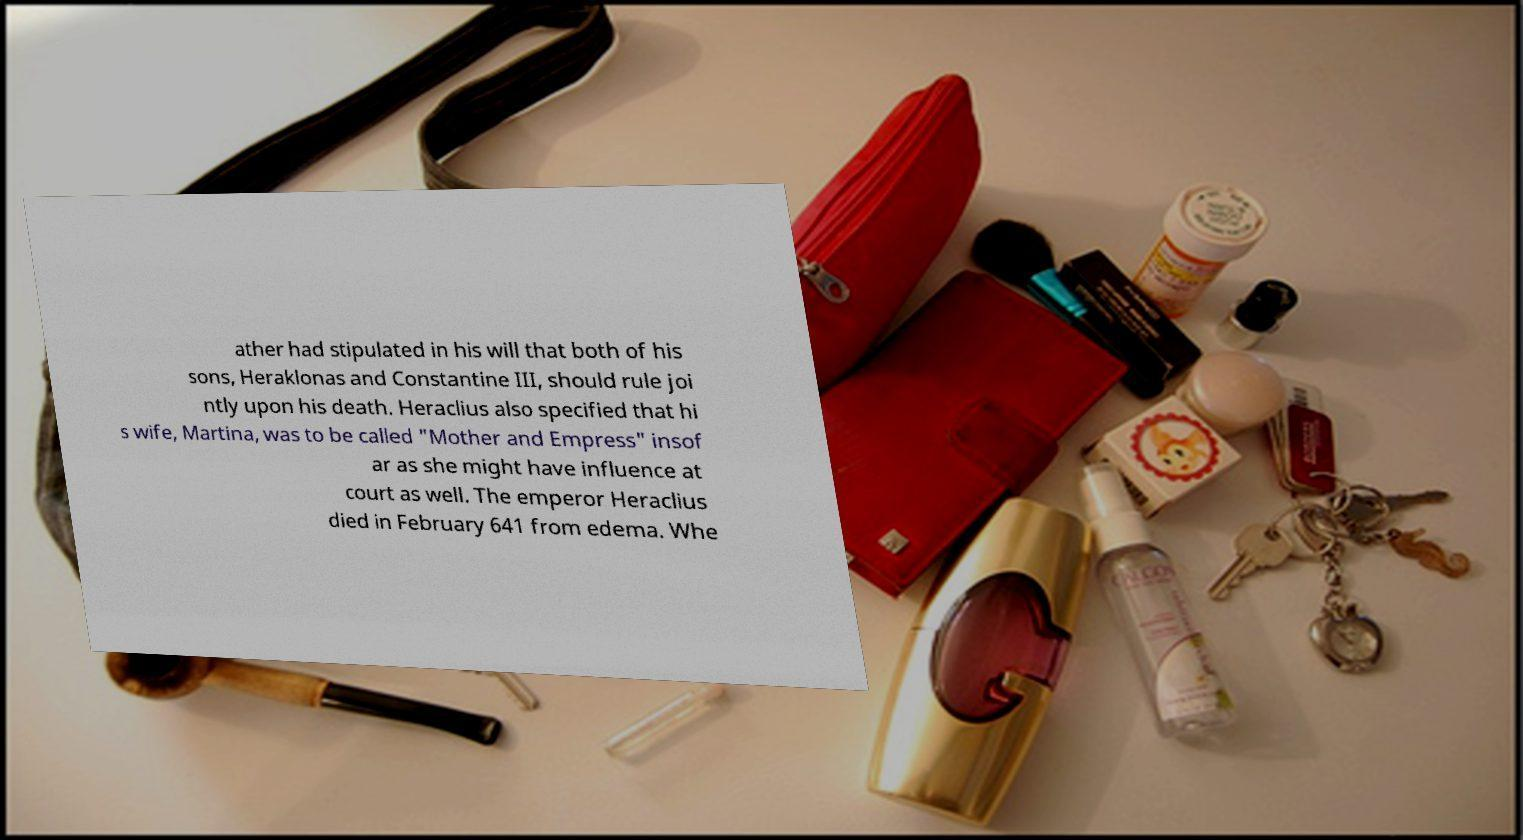Please read and relay the text visible in this image. What does it say? ather had stipulated in his will that both of his sons, Heraklonas and Constantine III, should rule joi ntly upon his death. Heraclius also specified that hi s wife, Martina, was to be called "Mother and Empress" insof ar as she might have influence at court as well. The emperor Heraclius died in February 641 from edema. Whe 